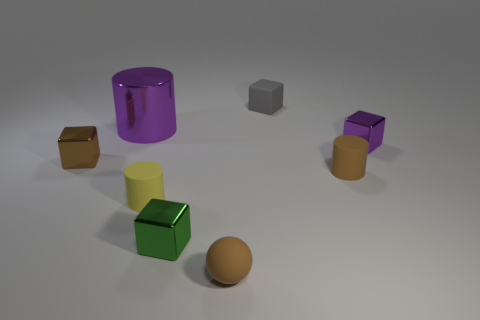There is a small gray thing that is the same shape as the small purple thing; what is it made of?
Your answer should be compact. Rubber. Do the cube on the left side of the yellow cylinder and the big purple cylinder have the same size?
Offer a very short reply. No. There is a thing that is to the right of the tiny green shiny thing and in front of the yellow thing; what color is it?
Give a very brief answer. Brown. How many brown things are in front of the brown thing that is left of the green metallic cube?
Offer a very short reply. 2. Does the tiny purple shiny thing have the same shape as the yellow thing?
Provide a succinct answer. No. Is there anything else of the same color as the small sphere?
Ensure brevity in your answer.  Yes. There is a green thing; does it have the same shape as the rubber thing on the left side of the small ball?
Offer a very short reply. No. What color is the metal object that is right of the green thing that is on the left side of the small brown rubber object in front of the small brown cylinder?
Make the answer very short. Purple. Is there any other thing that is made of the same material as the small brown cylinder?
Offer a terse response. Yes. Do the shiny object that is behind the tiny purple cube and the gray thing have the same shape?
Give a very brief answer. No. 